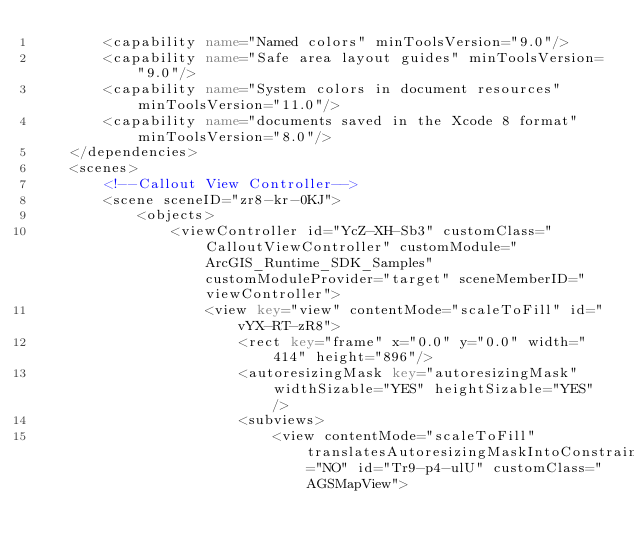<code> <loc_0><loc_0><loc_500><loc_500><_XML_>        <capability name="Named colors" minToolsVersion="9.0"/>
        <capability name="Safe area layout guides" minToolsVersion="9.0"/>
        <capability name="System colors in document resources" minToolsVersion="11.0"/>
        <capability name="documents saved in the Xcode 8 format" minToolsVersion="8.0"/>
    </dependencies>
    <scenes>
        <!--Callout View Controller-->
        <scene sceneID="zr8-kr-0KJ">
            <objects>
                <viewController id="YcZ-XH-Sb3" customClass="CalloutViewController" customModule="ArcGIS_Runtime_SDK_Samples" customModuleProvider="target" sceneMemberID="viewController">
                    <view key="view" contentMode="scaleToFill" id="vYX-RT-zR8">
                        <rect key="frame" x="0.0" y="0.0" width="414" height="896"/>
                        <autoresizingMask key="autoresizingMask" widthSizable="YES" heightSizable="YES"/>
                        <subviews>
                            <view contentMode="scaleToFill" translatesAutoresizingMaskIntoConstraints="NO" id="Tr9-p4-ulU" customClass="AGSMapView"></code> 